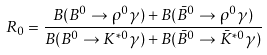Convert formula to latex. <formula><loc_0><loc_0><loc_500><loc_500>R _ { 0 } = \frac { B ( B ^ { 0 } \to \rho ^ { 0 } \gamma ) + B ( \bar { B } ^ { 0 } \to \rho ^ { 0 } \gamma ) } { B ( B ^ { 0 } \to K ^ { * 0 } \gamma ) + B ( \bar { B } ^ { 0 } \to \bar { K } ^ { * 0 } \gamma ) }</formula> 